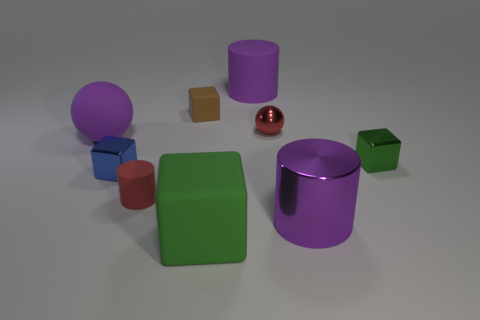Subtract all purple cylinders. How many cylinders are left? 1 Subtract all brown cubes. How many cubes are left? 3 Subtract 1 cubes. How many cubes are left? 3 Subtract all yellow cubes. How many purple cylinders are left? 2 Add 1 small brown matte blocks. How many objects exist? 10 Subtract 0 cyan balls. How many objects are left? 9 Subtract all blocks. How many objects are left? 5 Subtract all gray cubes. Subtract all gray spheres. How many cubes are left? 4 Subtract all large purple things. Subtract all tiny objects. How many objects are left? 1 Add 9 big purple rubber spheres. How many big purple rubber spheres are left? 10 